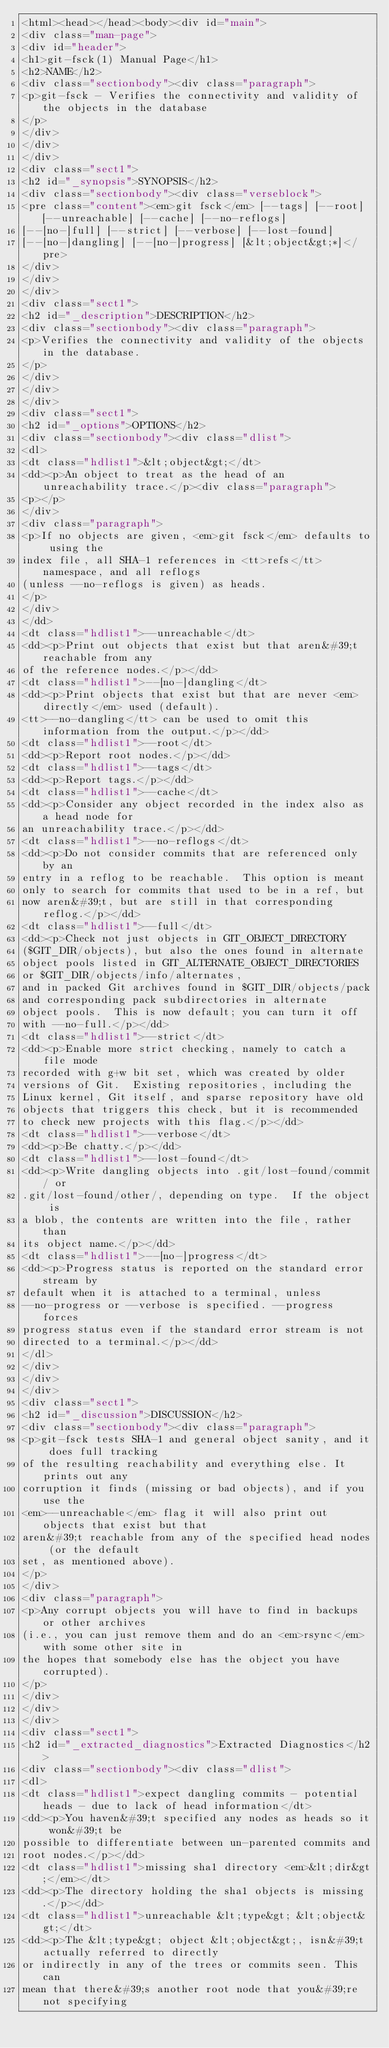Convert code to text. <code><loc_0><loc_0><loc_500><loc_500><_HTML_><html><head></head><body><div id="main">
<div class="man-page">
<div id="header">
<h1>git-fsck(1) Manual Page</h1>
<h2>NAME</h2>
<div class="sectionbody"><div class="paragraph">
<p>git-fsck - Verifies the connectivity and validity of the objects in the database
</p>
</div>
</div>
</div>
<div class="sect1">
<h2 id="_synopsis">SYNOPSIS</h2>
<div class="sectionbody"><div class="verseblock">
<pre class="content"><em>git fsck</em> [--tags] [--root] [--unreachable] [--cache] [--no-reflogs]
[--[no-]full] [--strict] [--verbose] [--lost-found]
[--[no-]dangling] [--[no-]progress] [&lt;object&gt;*]</pre>
</div>
</div>
</div>
<div class="sect1">
<h2 id="_description">DESCRIPTION</h2>
<div class="sectionbody"><div class="paragraph">
<p>Verifies the connectivity and validity of the objects in the database.
</p>
</div>
</div>
</div>
<div class="sect1">
<h2 id="_options">OPTIONS</h2>
<div class="sectionbody"><div class="dlist">
<dl>
<dt class="hdlist1">&lt;object&gt;</dt>
<dd><p>An object to treat as the head of an unreachability trace.</p><div class="paragraph">
<p></p>
</div>
<div class="paragraph">
<p>If no objects are given, <em>git fsck</em> defaults to using the
index file, all SHA-1 references in <tt>refs</tt> namespace, and all reflogs
(unless --no-reflogs is given) as heads.
</p>
</div>
</dd>
<dt class="hdlist1">--unreachable</dt>
<dd><p>Print out objects that exist but that aren&#39;t reachable from any
of the reference nodes.</p></dd>
<dt class="hdlist1">--[no-]dangling</dt>
<dd><p>Print objects that exist but that are never <em>directly</em> used (default).
<tt>--no-dangling</tt> can be used to omit this information from the output.</p></dd>
<dt class="hdlist1">--root</dt>
<dd><p>Report root nodes.</p></dd>
<dt class="hdlist1">--tags</dt>
<dd><p>Report tags.</p></dd>
<dt class="hdlist1">--cache</dt>
<dd><p>Consider any object recorded in the index also as a head node for
an unreachability trace.</p></dd>
<dt class="hdlist1">--no-reflogs</dt>
<dd><p>Do not consider commits that are referenced only by an
entry in a reflog to be reachable.  This option is meant
only to search for commits that used to be in a ref, but
now aren&#39;t, but are still in that corresponding reflog.</p></dd>
<dt class="hdlist1">--full</dt>
<dd><p>Check not just objects in GIT_OBJECT_DIRECTORY
($GIT_DIR/objects), but also the ones found in alternate
object pools listed in GIT_ALTERNATE_OBJECT_DIRECTORIES
or $GIT_DIR/objects/info/alternates,
and in packed Git archives found in $GIT_DIR/objects/pack
and corresponding pack subdirectories in alternate
object pools.  This is now default; you can turn it off
with --no-full.</p></dd>
<dt class="hdlist1">--strict</dt>
<dd><p>Enable more strict checking, namely to catch a file mode
recorded with g+w bit set, which was created by older
versions of Git.  Existing repositories, including the
Linux kernel, Git itself, and sparse repository have old
objects that triggers this check, but it is recommended
to check new projects with this flag.</p></dd>
<dt class="hdlist1">--verbose</dt>
<dd><p>Be chatty.</p></dd>
<dt class="hdlist1">--lost-found</dt>
<dd><p>Write dangling objects into .git/lost-found/commit/ or
.git/lost-found/other/, depending on type.  If the object is
a blob, the contents are written into the file, rather than
its object name.</p></dd>
<dt class="hdlist1">--[no-]progress</dt>
<dd><p>Progress status is reported on the standard error stream by
default when it is attached to a terminal, unless
--no-progress or --verbose is specified. --progress forces
progress status even if the standard error stream is not
directed to a terminal.</p></dd>
</dl>
</div>
</div>
</div>
<div class="sect1">
<h2 id="_discussion">DISCUSSION</h2>
<div class="sectionbody"><div class="paragraph">
<p>git-fsck tests SHA-1 and general object sanity, and it does full tracking
of the resulting reachability and everything else. It prints out any
corruption it finds (missing or bad objects), and if you use the
<em>--unreachable</em> flag it will also print out objects that exist but that
aren&#39;t reachable from any of the specified head nodes (or the default
set, as mentioned above).
</p>
</div>
<div class="paragraph">
<p>Any corrupt objects you will have to find in backups or other archives
(i.e., you can just remove them and do an <em>rsync</em> with some other site in
the hopes that somebody else has the object you have corrupted).
</p>
</div>
</div>
</div>
<div class="sect1">
<h2 id="_extracted_diagnostics">Extracted Diagnostics</h2>
<div class="sectionbody"><div class="dlist">
<dl>
<dt class="hdlist1">expect dangling commits - potential heads - due to lack of head information</dt>
<dd><p>You haven&#39;t specified any nodes as heads so it won&#39;t be
possible to differentiate between un-parented commits and
root nodes.</p></dd>
<dt class="hdlist1">missing sha1 directory <em>&lt;dir&gt;</em></dt>
<dd><p>The directory holding the sha1 objects is missing.</p></dd>
<dt class="hdlist1">unreachable &lt;type&gt; &lt;object&gt;</dt>
<dd><p>The &lt;type&gt; object &lt;object&gt;, isn&#39;t actually referred to directly
or indirectly in any of the trees or commits seen. This can
mean that there&#39;s another root node that you&#39;re not specifying</code> 